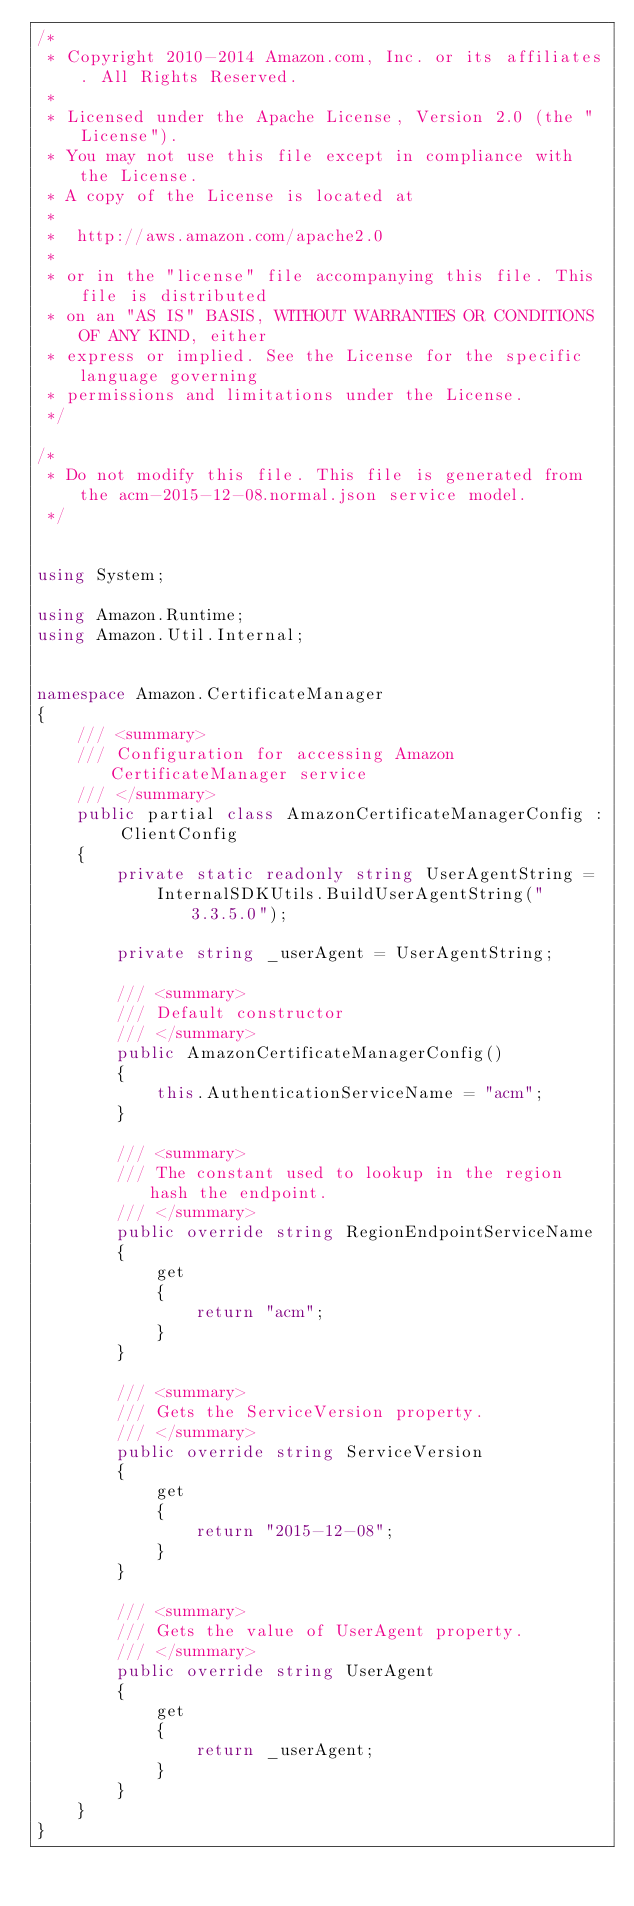Convert code to text. <code><loc_0><loc_0><loc_500><loc_500><_C#_>/*
 * Copyright 2010-2014 Amazon.com, Inc. or its affiliates. All Rights Reserved.
 * 
 * Licensed under the Apache License, Version 2.0 (the "License").
 * You may not use this file except in compliance with the License.
 * A copy of the License is located at
 * 
 *  http://aws.amazon.com/apache2.0
 * 
 * or in the "license" file accompanying this file. This file is distributed
 * on an "AS IS" BASIS, WITHOUT WARRANTIES OR CONDITIONS OF ANY KIND, either
 * express or implied. See the License for the specific language governing
 * permissions and limitations under the License.
 */

/*
 * Do not modify this file. This file is generated from the acm-2015-12-08.normal.json service model.
 */


using System;

using Amazon.Runtime;
using Amazon.Util.Internal;


namespace Amazon.CertificateManager
{
    /// <summary>
    /// Configuration for accessing Amazon CertificateManager service
    /// </summary>
    public partial class AmazonCertificateManagerConfig : ClientConfig
    {
        private static readonly string UserAgentString =
            InternalSDKUtils.BuildUserAgentString("3.3.5.0");

        private string _userAgent = UserAgentString;

        /// <summary>
        /// Default constructor
        /// </summary>
        public AmazonCertificateManagerConfig()
        {
            this.AuthenticationServiceName = "acm";
        }

        /// <summary>
        /// The constant used to lookup in the region hash the endpoint.
        /// </summary>
        public override string RegionEndpointServiceName
        {
            get
            {
                return "acm";
            }
        }

        /// <summary>
        /// Gets the ServiceVersion property.
        /// </summary>
        public override string ServiceVersion
        {
            get
            {
                return "2015-12-08";
            }
        }

        /// <summary>
        /// Gets the value of UserAgent property.
        /// </summary>
        public override string UserAgent
        {
            get
            {
                return _userAgent;
            }
        }
    }
}</code> 